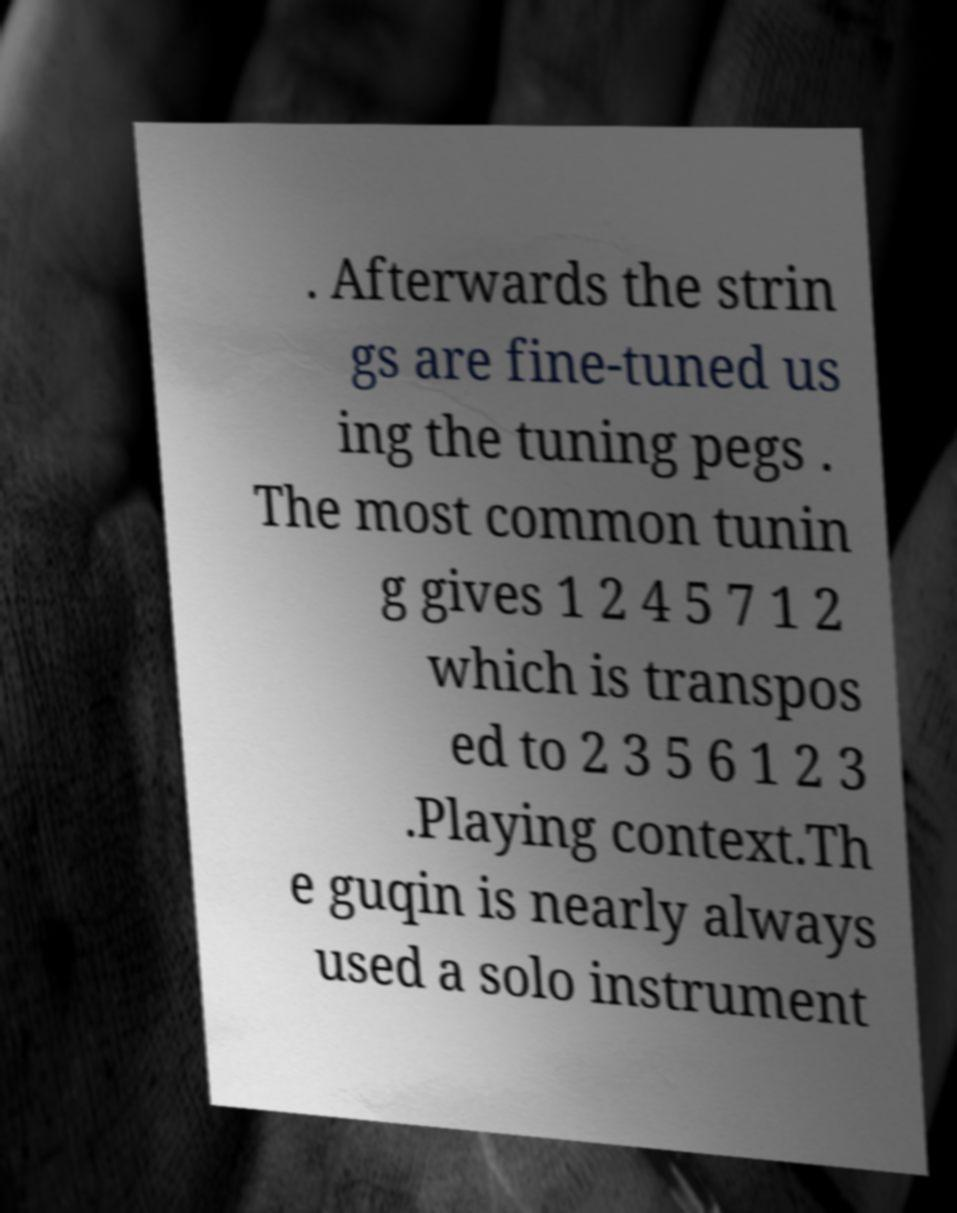I need the written content from this picture converted into text. Can you do that? . Afterwards the strin gs are fine-tuned us ing the tuning pegs . The most common tunin g gives 1 2 4 5 7 1 2 which is transpos ed to 2 3 5 6 1 2 3 .Playing context.Th e guqin is nearly always used a solo instrument 